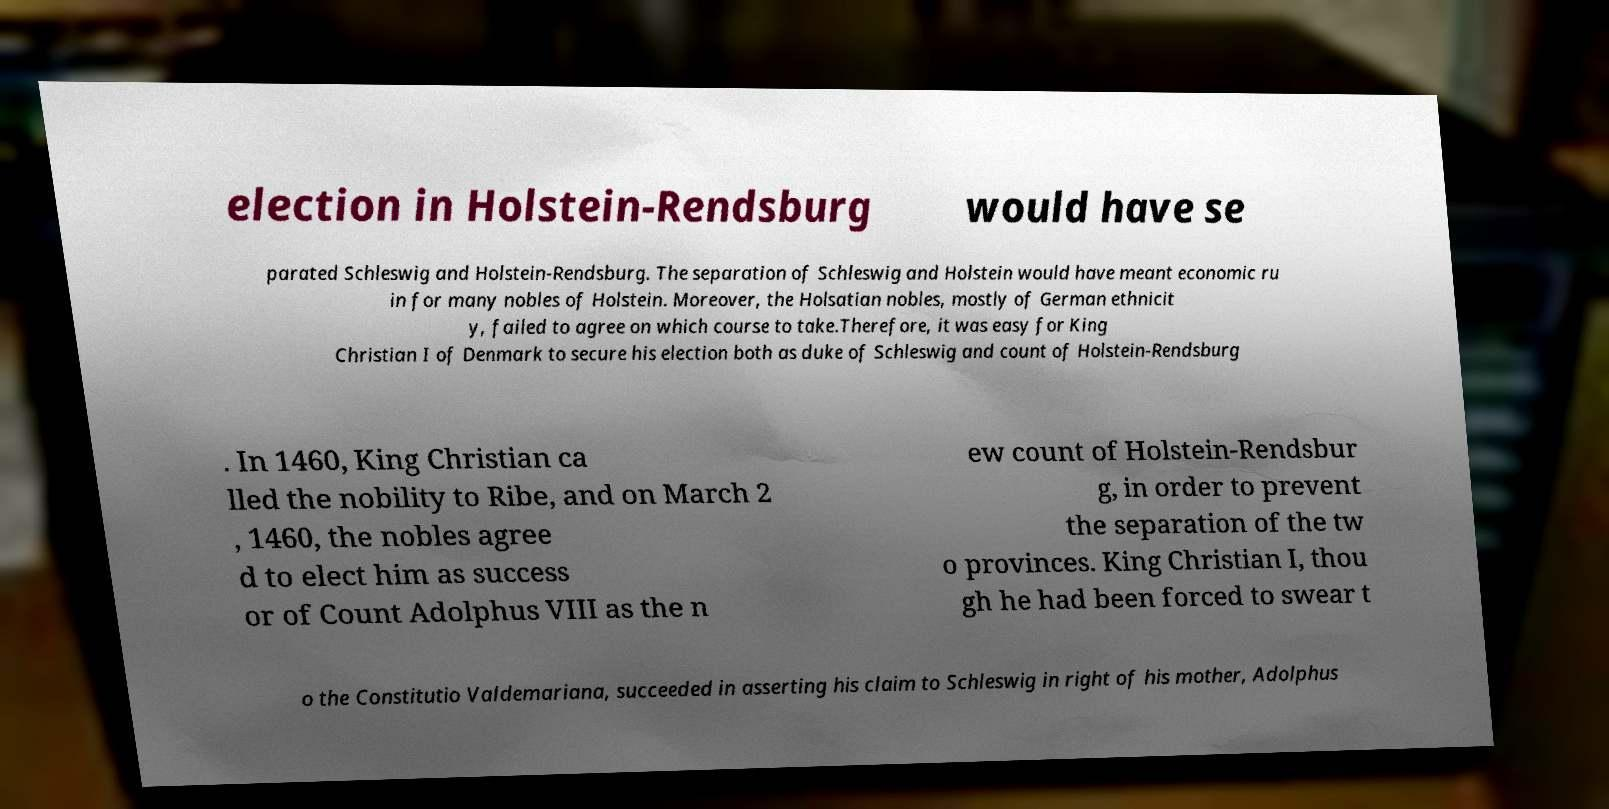What messages or text are displayed in this image? I need them in a readable, typed format. election in Holstein-Rendsburg would have se parated Schleswig and Holstein-Rendsburg. The separation of Schleswig and Holstein would have meant economic ru in for many nobles of Holstein. Moreover, the Holsatian nobles, mostly of German ethnicit y, failed to agree on which course to take.Therefore, it was easy for King Christian I of Denmark to secure his election both as duke of Schleswig and count of Holstein-Rendsburg . In 1460, King Christian ca lled the nobility to Ribe, and on March 2 , 1460, the nobles agree d to elect him as success or of Count Adolphus VIII as the n ew count of Holstein-Rendsbur g, in order to prevent the separation of the tw o provinces. King Christian I, thou gh he had been forced to swear t o the Constitutio Valdemariana, succeeded in asserting his claim to Schleswig in right of his mother, Adolphus 